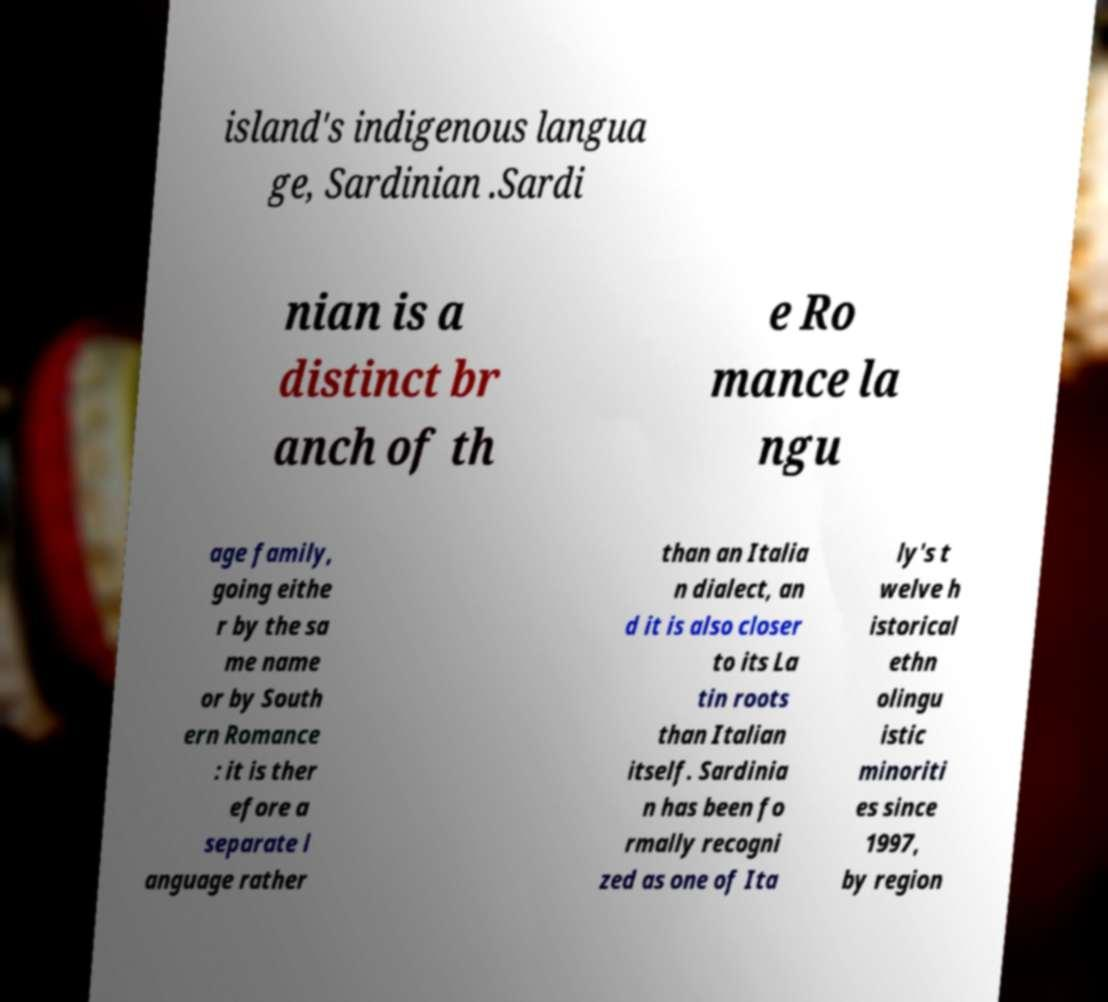For documentation purposes, I need the text within this image transcribed. Could you provide that? island's indigenous langua ge, Sardinian .Sardi nian is a distinct br anch of th e Ro mance la ngu age family, going eithe r by the sa me name or by South ern Romance : it is ther efore a separate l anguage rather than an Italia n dialect, an d it is also closer to its La tin roots than Italian itself. Sardinia n has been fo rmally recogni zed as one of Ita ly's t welve h istorical ethn olingu istic minoriti es since 1997, by region 